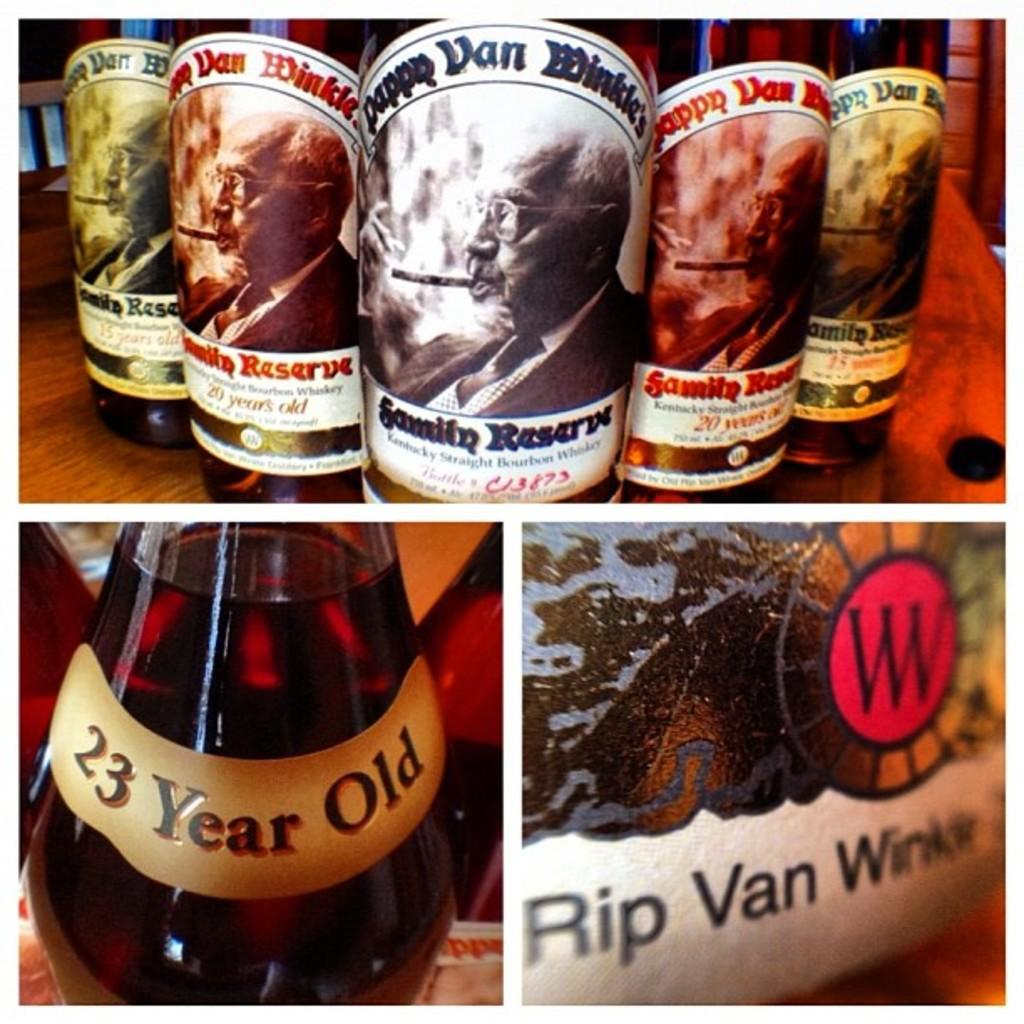<image>
Summarize the visual content of the image. One of the brands of whiskey is named Rip Van Winkle. 